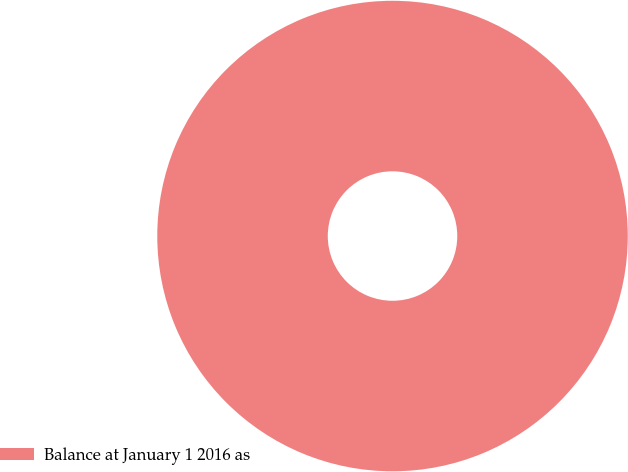Convert chart to OTSL. <chart><loc_0><loc_0><loc_500><loc_500><pie_chart><fcel>Balance at January 1 2016 as<nl><fcel>100.0%<nl></chart> 